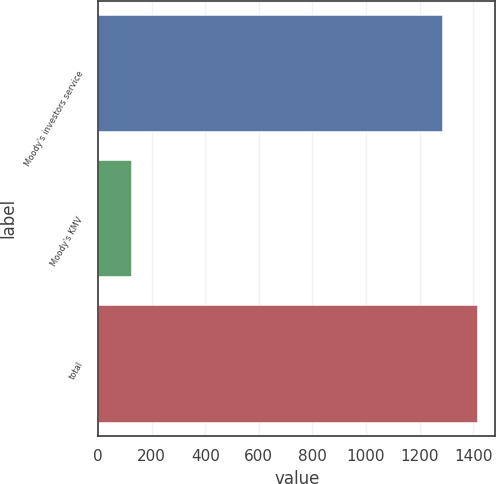Convert chart to OTSL. <chart><loc_0><loc_0><loc_500><loc_500><bar_chart><fcel>Moody's investors service<fcel>Moody's KMV<fcel>total<nl><fcel>1284<fcel>122<fcel>1412.4<nl></chart> 